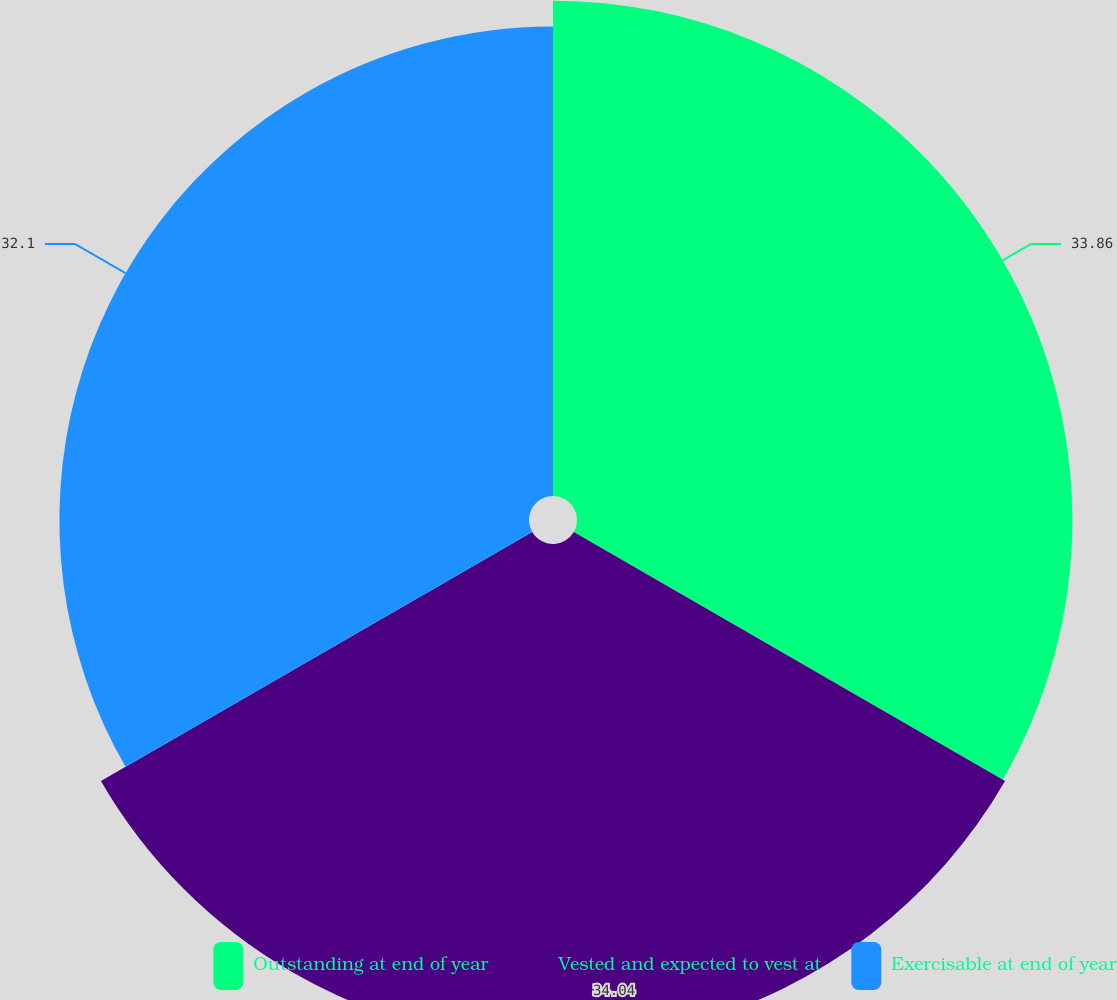Convert chart. <chart><loc_0><loc_0><loc_500><loc_500><pie_chart><fcel>Outstanding at end of year<fcel>Vested and expected to vest at<fcel>Exercisable at end of year<nl><fcel>33.86%<fcel>34.04%<fcel>32.1%<nl></chart> 